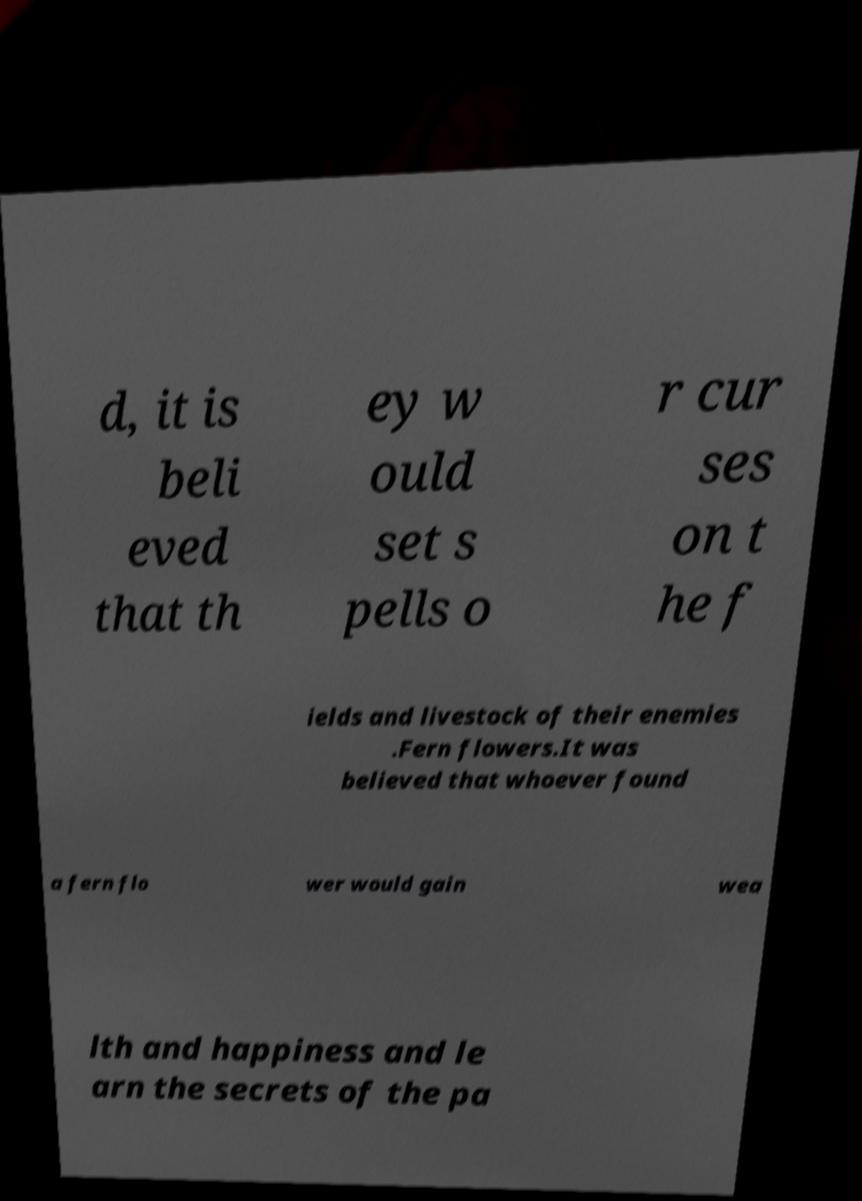Could you extract and type out the text from this image? d, it is beli eved that th ey w ould set s pells o r cur ses on t he f ields and livestock of their enemies .Fern flowers.It was believed that whoever found a fern flo wer would gain wea lth and happiness and le arn the secrets of the pa 